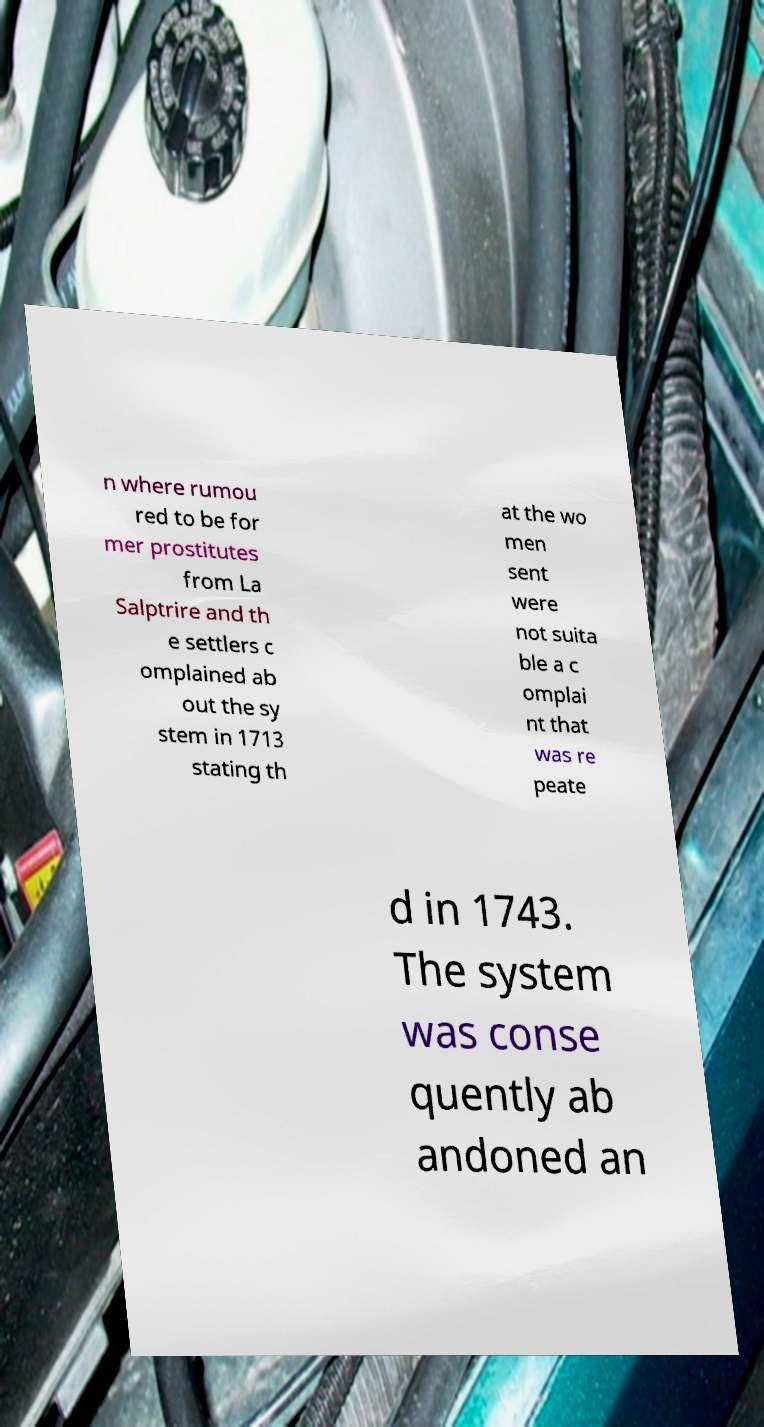Please read and relay the text visible in this image. What does it say? n where rumou red to be for mer prostitutes from La Salptrire and th e settlers c omplained ab out the sy stem in 1713 stating th at the wo men sent were not suita ble a c omplai nt that was re peate d in 1743. The system was conse quently ab andoned an 